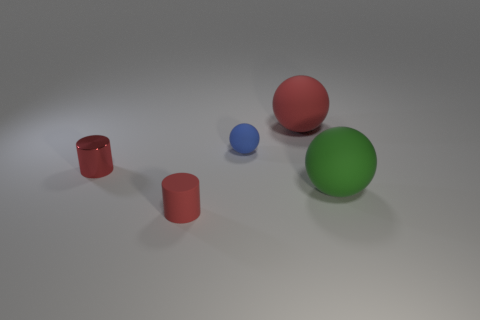There is a big rubber object that is the same color as the tiny matte cylinder; what shape is it?
Offer a terse response. Sphere. Is the color of the cylinder that is left of the tiny red rubber cylinder the same as the thing behind the blue thing?
Your response must be concise. Yes. What shape is the tiny red object that is the same material as the big red sphere?
Keep it short and to the point. Cylinder. How big is the red rubber object that is in front of the large ball behind the tiny sphere?
Give a very brief answer. Small. What is the color of the object that is behind the blue rubber thing?
Make the answer very short. Red. Are there any tiny metallic objects that have the same shape as the large green object?
Your response must be concise. No. Is the number of small red rubber things that are in front of the tiny red matte object less than the number of large green things that are in front of the tiny rubber sphere?
Ensure brevity in your answer.  Yes. What is the color of the shiny cylinder?
Offer a terse response. Red. Are there any red matte things that are left of the rubber object that is behind the small sphere?
Give a very brief answer. Yes. What number of blue rubber objects have the same size as the blue sphere?
Your response must be concise. 0. 